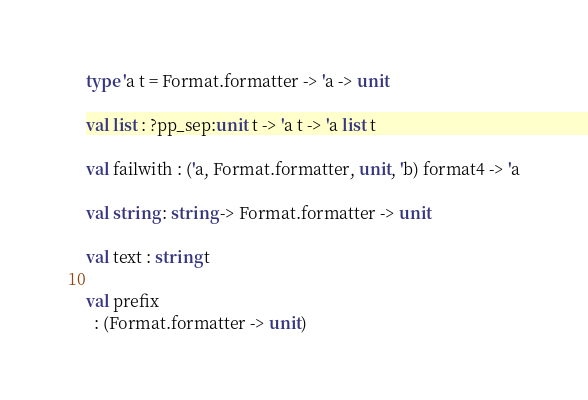<code> <loc_0><loc_0><loc_500><loc_500><_OCaml_>type 'a t = Format.formatter -> 'a -> unit

val list : ?pp_sep:unit t -> 'a t -> 'a list t

val failwith : ('a, Format.formatter, unit, 'b) format4 -> 'a

val string : string -> Format.formatter -> unit

val text : string t

val prefix
  : (Format.formatter -> unit)</code> 